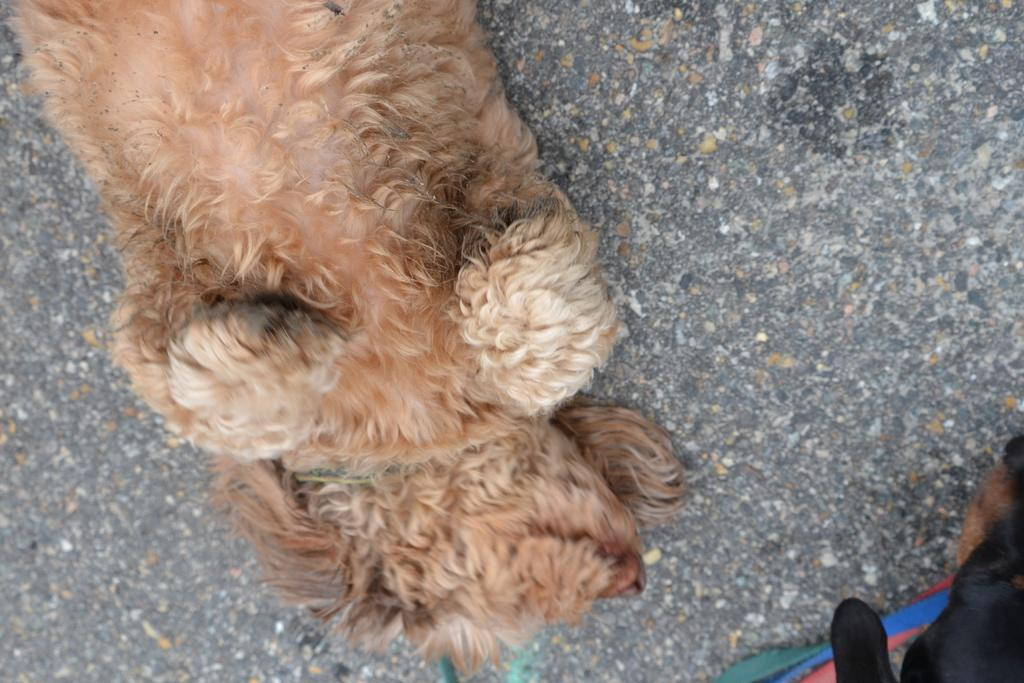What type of animal can be seen in the image? There is a brown dog in the image. What is the brown dog doing in the image? The brown dog is resting on the ground. Are there any other animals visible in the image? Yes, there is another dog in the bottom right of the image. What type of rhythm does the brick have in the image? There is no brick present in the image, so it is not possible to determine its rhythm. 